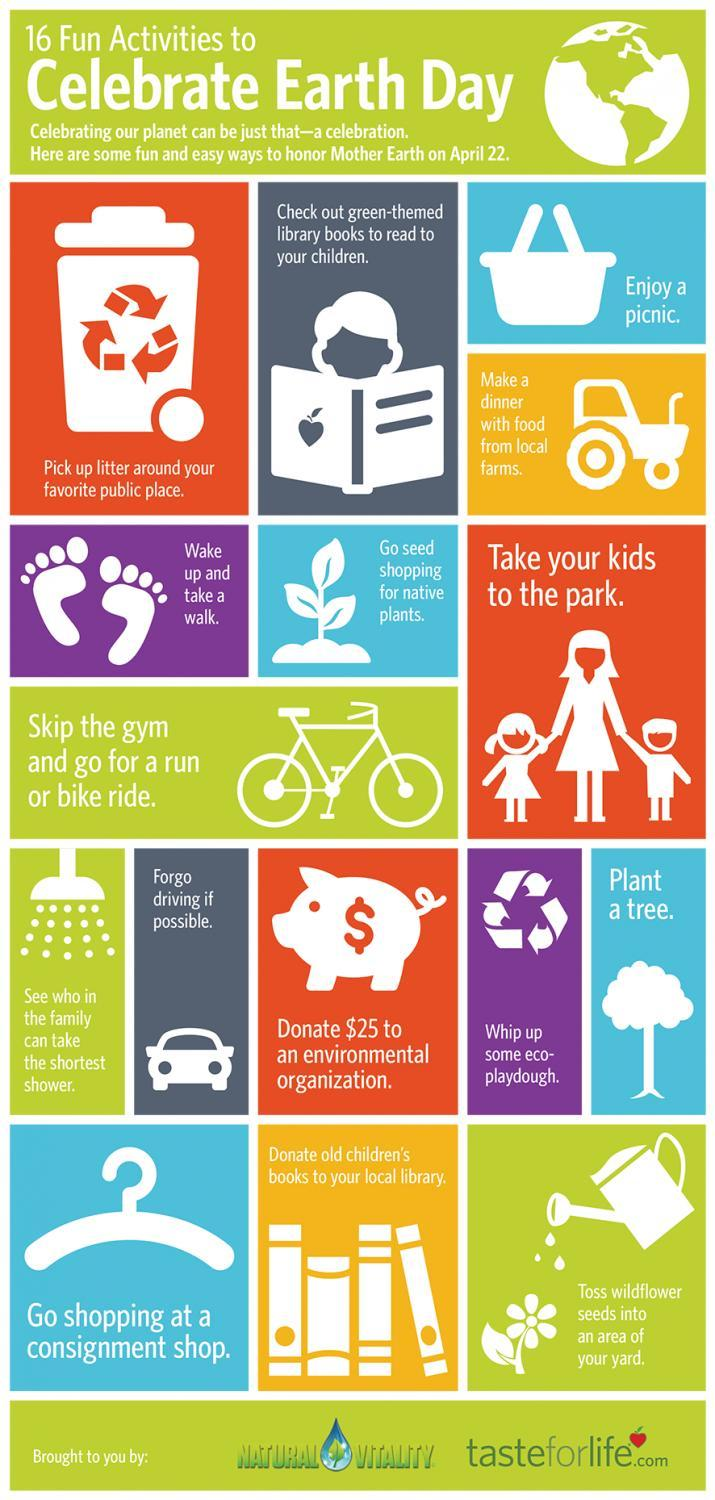Which is the fifth activity to celebrate on Earth day?
Answer the question with a short phrase. Wake up and take a walk. Which is the third activity to celebrate on Earth day? Enjoy a picnic. Which is the sixth activity to celebrate on Earth day? Go seed shopping for native plants. Which is the fourth activity to celebrate on Earth day? Make a dinner with food from local farms. 